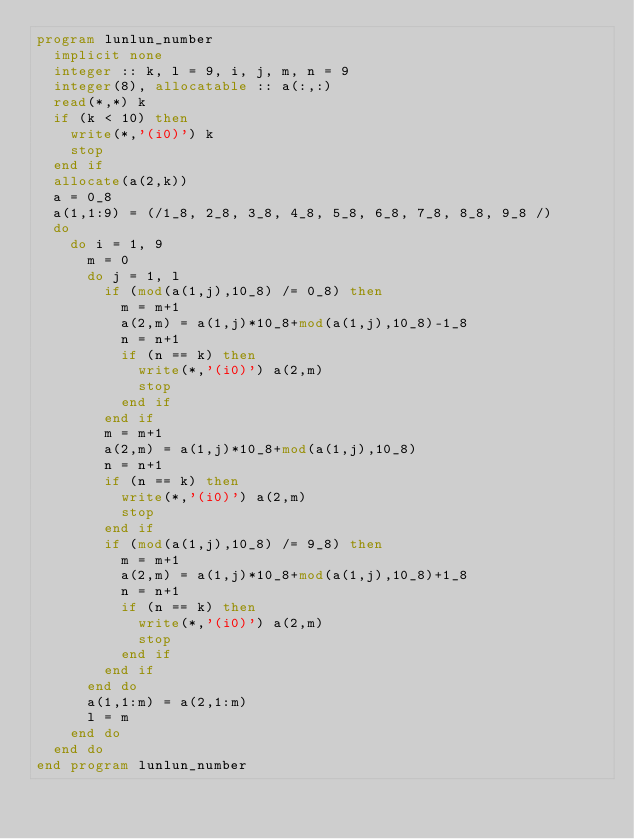Convert code to text. <code><loc_0><loc_0><loc_500><loc_500><_FORTRAN_>program lunlun_number
  implicit none
  integer :: k, l = 9, i, j, m, n = 9
  integer(8), allocatable :: a(:,:)
  read(*,*) k
  if (k < 10) then
    write(*,'(i0)') k
    stop
  end if
  allocate(a(2,k))
  a = 0_8
  a(1,1:9) = (/1_8, 2_8, 3_8, 4_8, 5_8, 6_8, 7_8, 8_8, 9_8 /)
  do
    do i = 1, 9
      m = 0
      do j = 1, l
        if (mod(a(1,j),10_8) /= 0_8) then
          m = m+1
          a(2,m) = a(1,j)*10_8+mod(a(1,j),10_8)-1_8
          n = n+1
          if (n == k) then
            write(*,'(i0)') a(2,m)
            stop
          end if
        end if
        m = m+1
        a(2,m) = a(1,j)*10_8+mod(a(1,j),10_8)
        n = n+1
        if (n == k) then
          write(*,'(i0)') a(2,m)
          stop
        end if
        if (mod(a(1,j),10_8) /= 9_8) then
          m = m+1
          a(2,m) = a(1,j)*10_8+mod(a(1,j),10_8)+1_8
          n = n+1
          if (n == k) then
            write(*,'(i0)') a(2,m)
            stop
          end if
        end if
      end do
      a(1,1:m) = a(2,1:m)
      l = m
    end do
  end do
end program lunlun_number</code> 